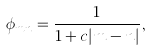Convert formula to latex. <formula><loc_0><loc_0><loc_500><loc_500>\phi _ { m n } = \frac { 1 } { 1 + c | m - n | } ,</formula> 